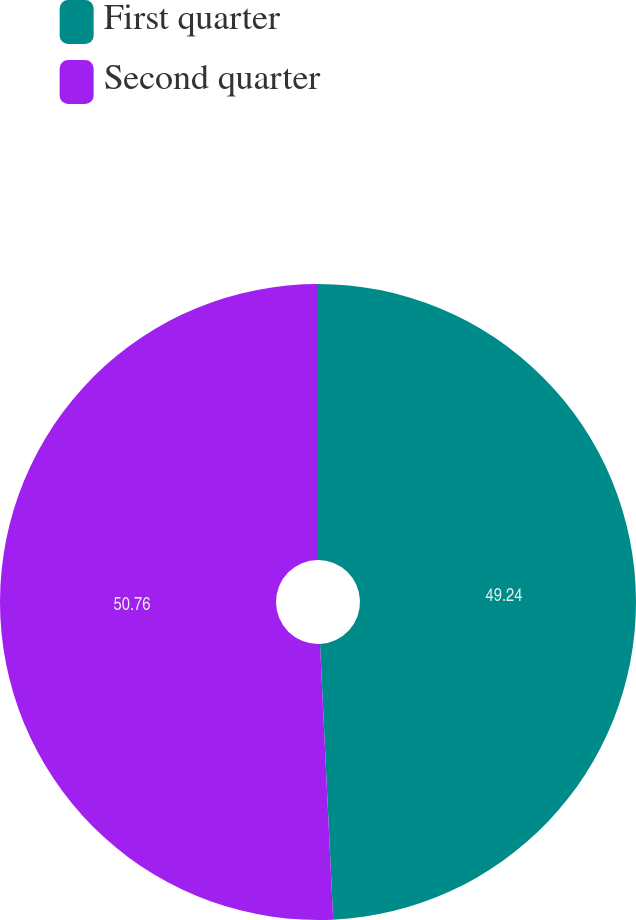Convert chart. <chart><loc_0><loc_0><loc_500><loc_500><pie_chart><fcel>First quarter<fcel>Second quarter<nl><fcel>49.24%<fcel>50.76%<nl></chart> 